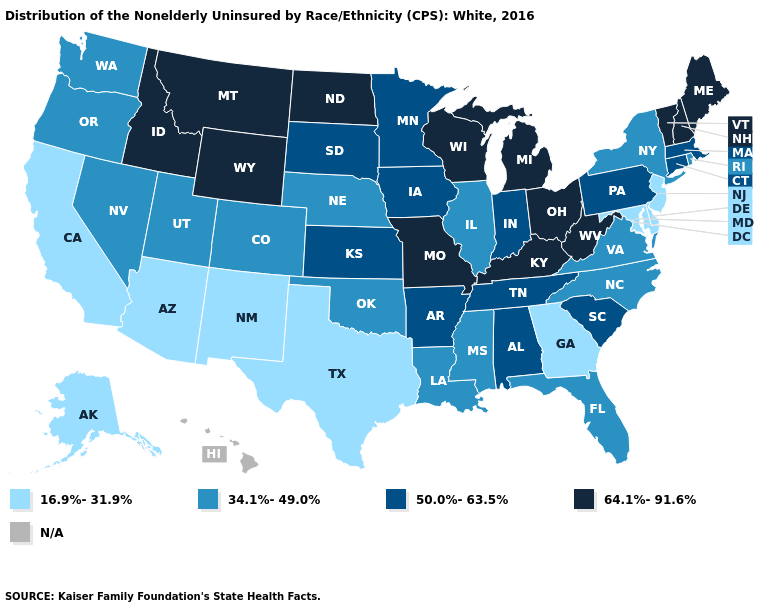Is the legend a continuous bar?
Give a very brief answer. No. Among the states that border Connecticut , does Massachusetts have the lowest value?
Give a very brief answer. No. What is the value of New Mexico?
Quick response, please. 16.9%-31.9%. Name the states that have a value in the range 50.0%-63.5%?
Answer briefly. Alabama, Arkansas, Connecticut, Indiana, Iowa, Kansas, Massachusetts, Minnesota, Pennsylvania, South Carolina, South Dakota, Tennessee. Which states have the highest value in the USA?
Answer briefly. Idaho, Kentucky, Maine, Michigan, Missouri, Montana, New Hampshire, North Dakota, Ohio, Vermont, West Virginia, Wisconsin, Wyoming. What is the lowest value in the USA?
Concise answer only. 16.9%-31.9%. Which states have the highest value in the USA?
Quick response, please. Idaho, Kentucky, Maine, Michigan, Missouri, Montana, New Hampshire, North Dakota, Ohio, Vermont, West Virginia, Wisconsin, Wyoming. What is the value of New Hampshire?
Short answer required. 64.1%-91.6%. What is the value of Pennsylvania?
Concise answer only. 50.0%-63.5%. How many symbols are there in the legend?
Give a very brief answer. 5. What is the value of Maryland?
Short answer required. 16.9%-31.9%. What is the value of Alaska?
Concise answer only. 16.9%-31.9%. Does New York have the highest value in the Northeast?
Short answer required. No. Name the states that have a value in the range N/A?
Answer briefly. Hawaii. 